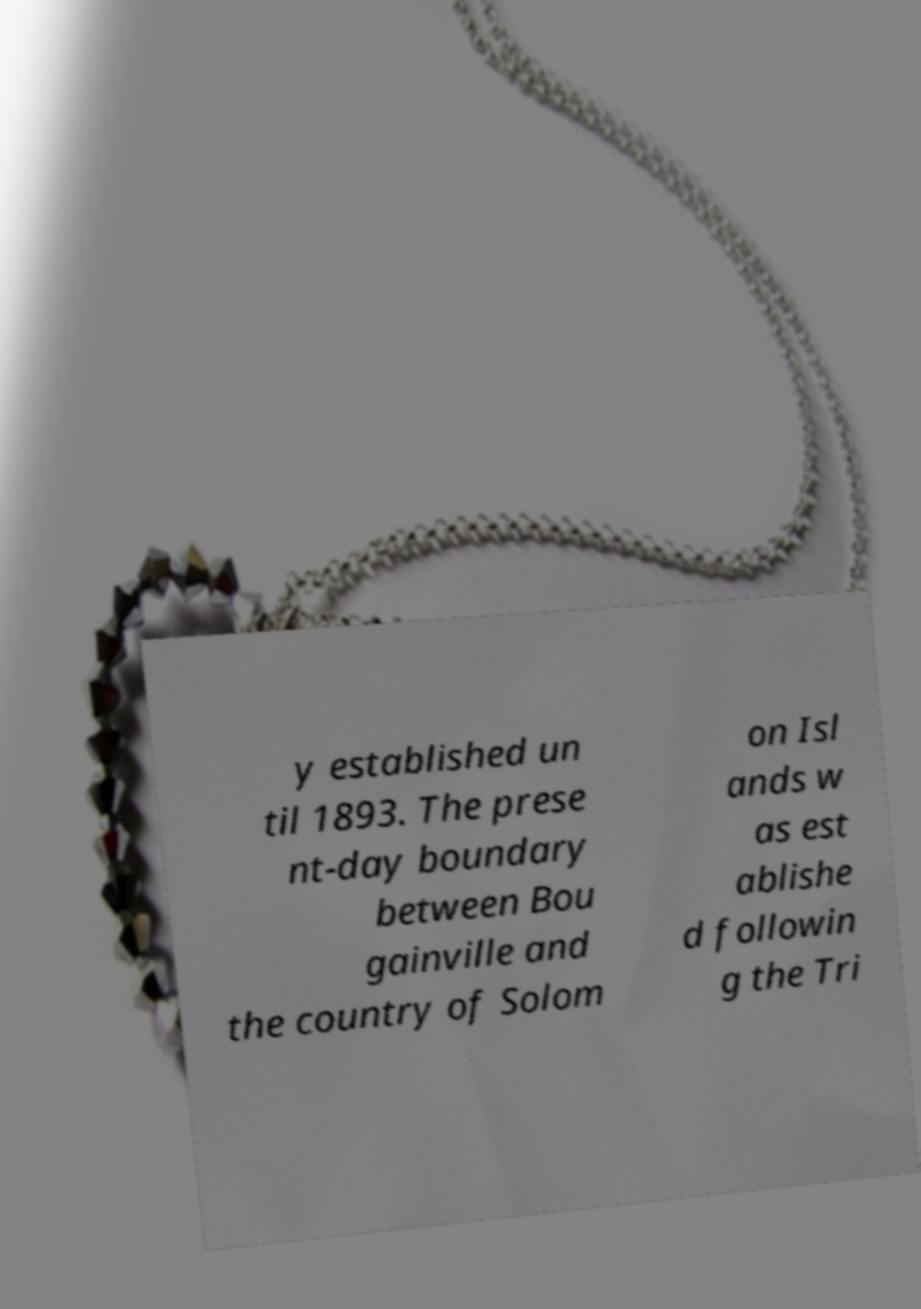There's text embedded in this image that I need extracted. Can you transcribe it verbatim? y established un til 1893. The prese nt-day boundary between Bou gainville and the country of Solom on Isl ands w as est ablishe d followin g the Tri 